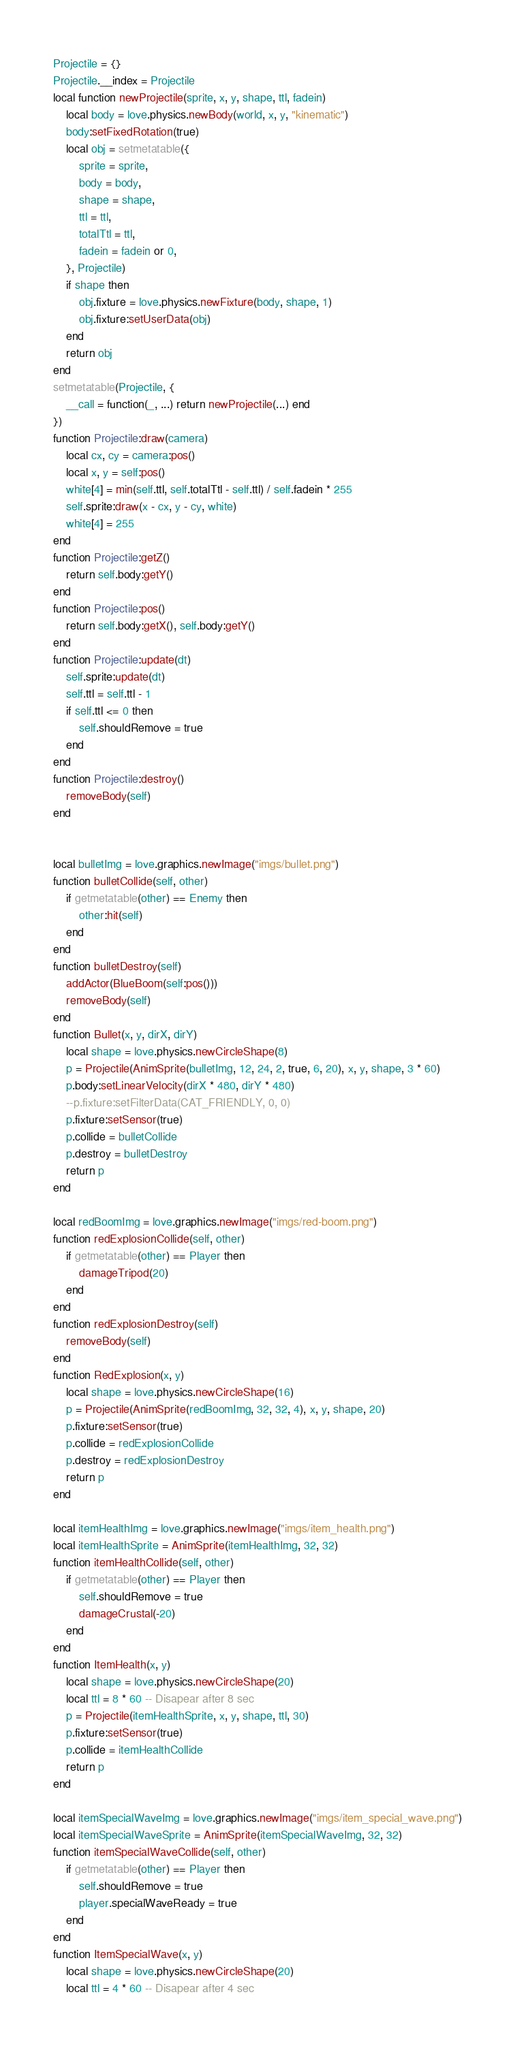<code> <loc_0><loc_0><loc_500><loc_500><_Lua_>Projectile = {}
Projectile.__index = Projectile
local function newProjectile(sprite, x, y, shape, ttl, fadein)
    local body = love.physics.newBody(world, x, y, "kinematic")
    body:setFixedRotation(true)
    local obj = setmetatable({
        sprite = sprite,
        body = body,
        shape = shape,
        ttl = ttl,
        totalTtl = ttl,
        fadein = fadein or 0,
    }, Projectile)
    if shape then
        obj.fixture = love.physics.newFixture(body, shape, 1)
        obj.fixture:setUserData(obj)
    end
    return obj
end
setmetatable(Projectile, {
    __call = function(_, ...) return newProjectile(...) end
})
function Projectile:draw(camera)
    local cx, cy = camera:pos()
    local x, y = self:pos()
    white[4] = min(self.ttl, self.totalTtl - self.ttl) / self.fadein * 255
    self.sprite:draw(x - cx, y - cy, white)
    white[4] = 255
end
function Projectile:getZ()
    return self.body:getY()
end
function Projectile:pos()
    return self.body:getX(), self.body:getY()
end
function Projectile:update(dt)
    self.sprite:update(dt)
    self.ttl = self.ttl - 1
    if self.ttl <= 0 then
        self.shouldRemove = true
    end
end
function Projectile:destroy()
    removeBody(self)
end


local bulletImg = love.graphics.newImage("imgs/bullet.png")
function bulletCollide(self, other)
    if getmetatable(other) == Enemy then
        other:hit(self)
    end
end
function bulletDestroy(self)
    addActor(BlueBoom(self:pos()))
    removeBody(self)
end
function Bullet(x, y, dirX, dirY)
    local shape = love.physics.newCircleShape(8)
    p = Projectile(AnimSprite(bulletImg, 12, 24, 2, true, 6, 20), x, y, shape, 3 * 60)
    p.body:setLinearVelocity(dirX * 480, dirY * 480)
    --p.fixture:setFilterData(CAT_FRIENDLY, 0, 0)
    p.fixture:setSensor(true)
    p.collide = bulletCollide
    p.destroy = bulletDestroy
    return p
end

local redBoomImg = love.graphics.newImage("imgs/red-boom.png")
function redExplosionCollide(self, other)
    if getmetatable(other) == Player then
        damageTripod(20)
    end
end
function redExplosionDestroy(self)
    removeBody(self)
end
function RedExplosion(x, y)
    local shape = love.physics.newCircleShape(16)
    p = Projectile(AnimSprite(redBoomImg, 32, 32, 4), x, y, shape, 20)
    p.fixture:setSensor(true)
    p.collide = redExplosionCollide
    p.destroy = redExplosionDestroy
    return p
end

local itemHealthImg = love.graphics.newImage("imgs/item_health.png")
local itemHealthSprite = AnimSprite(itemHealthImg, 32, 32)
function itemHealthCollide(self, other)
    if getmetatable(other) == Player then
        self.shouldRemove = true
        damageCrustal(-20)
    end
end
function ItemHealth(x, y)
    local shape = love.physics.newCircleShape(20)
    local ttl = 8 * 60 -- Disapear after 8 sec
    p = Projectile(itemHealthSprite, x, y, shape, ttl, 30)
    p.fixture:setSensor(true)
    p.collide = itemHealthCollide
    return p
end

local itemSpecialWaveImg = love.graphics.newImage("imgs/item_special_wave.png")
local itemSpecialWaveSprite = AnimSprite(itemSpecialWaveImg, 32, 32)
function itemSpecialWaveCollide(self, other)
    if getmetatable(other) == Player then
        self.shouldRemove = true
        player.specialWaveReady = true
    end
end
function ItemSpecialWave(x, y)
    local shape = love.physics.newCircleShape(20)
    local ttl = 4 * 60 -- Disapear after 4 sec</code> 